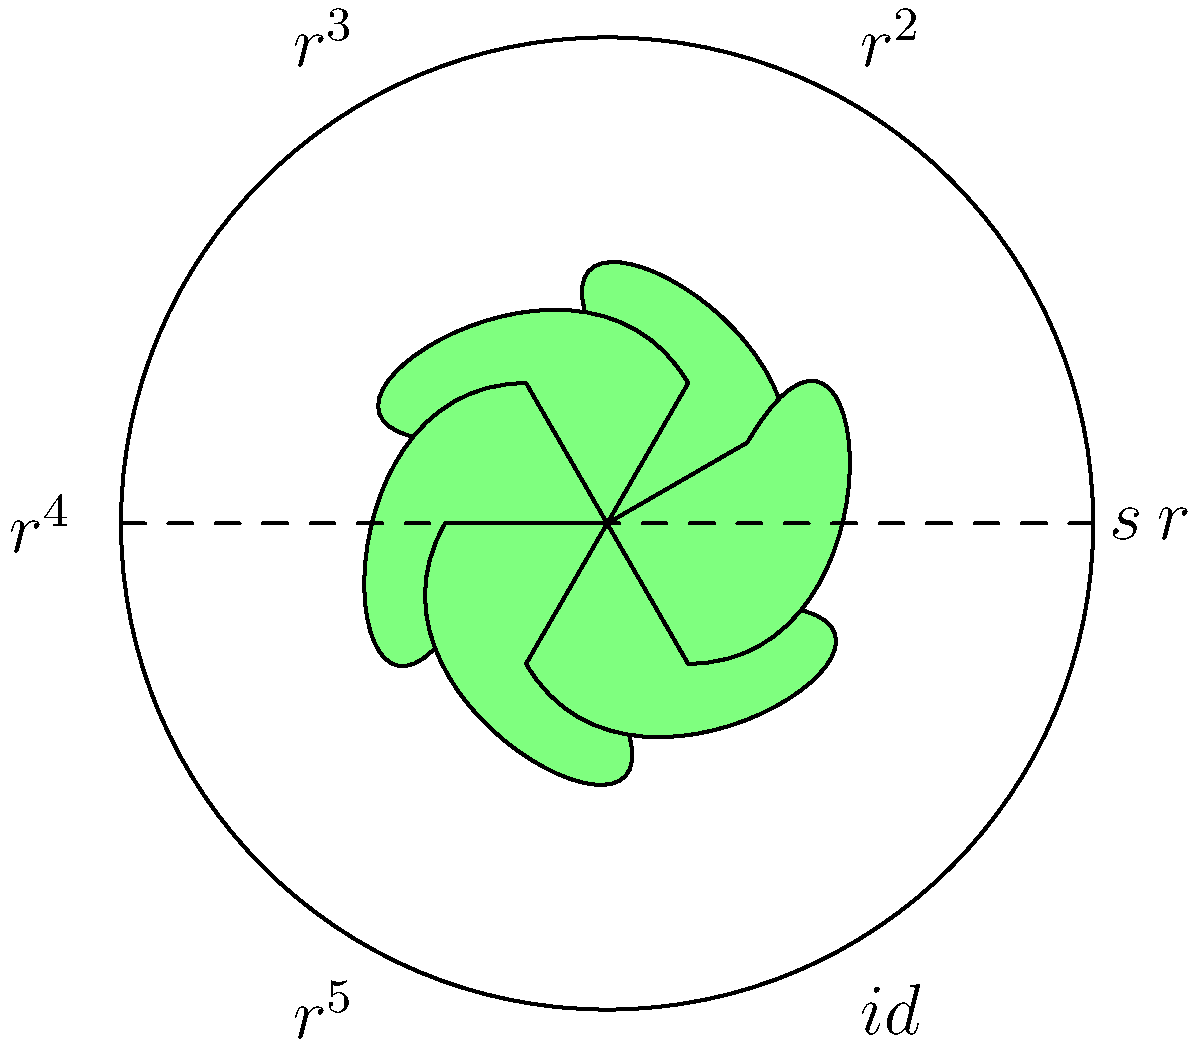Consider the classic cake decorating pattern shown above, consisting of six rosettes arranged in a circular pattern. The symmetry group of this pattern includes rotations and reflections. If $r$ represents a clockwise rotation of 60°, and $s$ represents a reflection across the horizontal axis, what is the result of applying the transformation $sr^2$ to the pattern? Let's approach this step-by-step:

1) First, we need to understand what $r^2$ means:
   - $r$ is a 60° clockwise rotation
   - $r^2$ is two 60° rotations, which is equivalent to a 120° clockwise rotation

2) Next, we apply $r^2$ to the pattern:
   - This moves each rosette two positions clockwise

3) After $r^2$, we apply $s$ (reflection across the horizontal axis):
   - This flips the entire pattern vertically

4) The combined effect of $sr^2$ is:
   - First rotate 120° clockwise
   - Then reflect across the horizontal axis

5) We can observe that this is equivalent to:
   - A counterclockwise rotation of 60° (which is $r^5$)
   - Followed by a reflection across the horizontal axis

6) In group theory notation, this can be written as:
   $sr^2 = r^5s$

This result demonstrates an important property of the dihedral group $D_6$, which is the symmetry group of this pattern.
Answer: $r^5s$ 